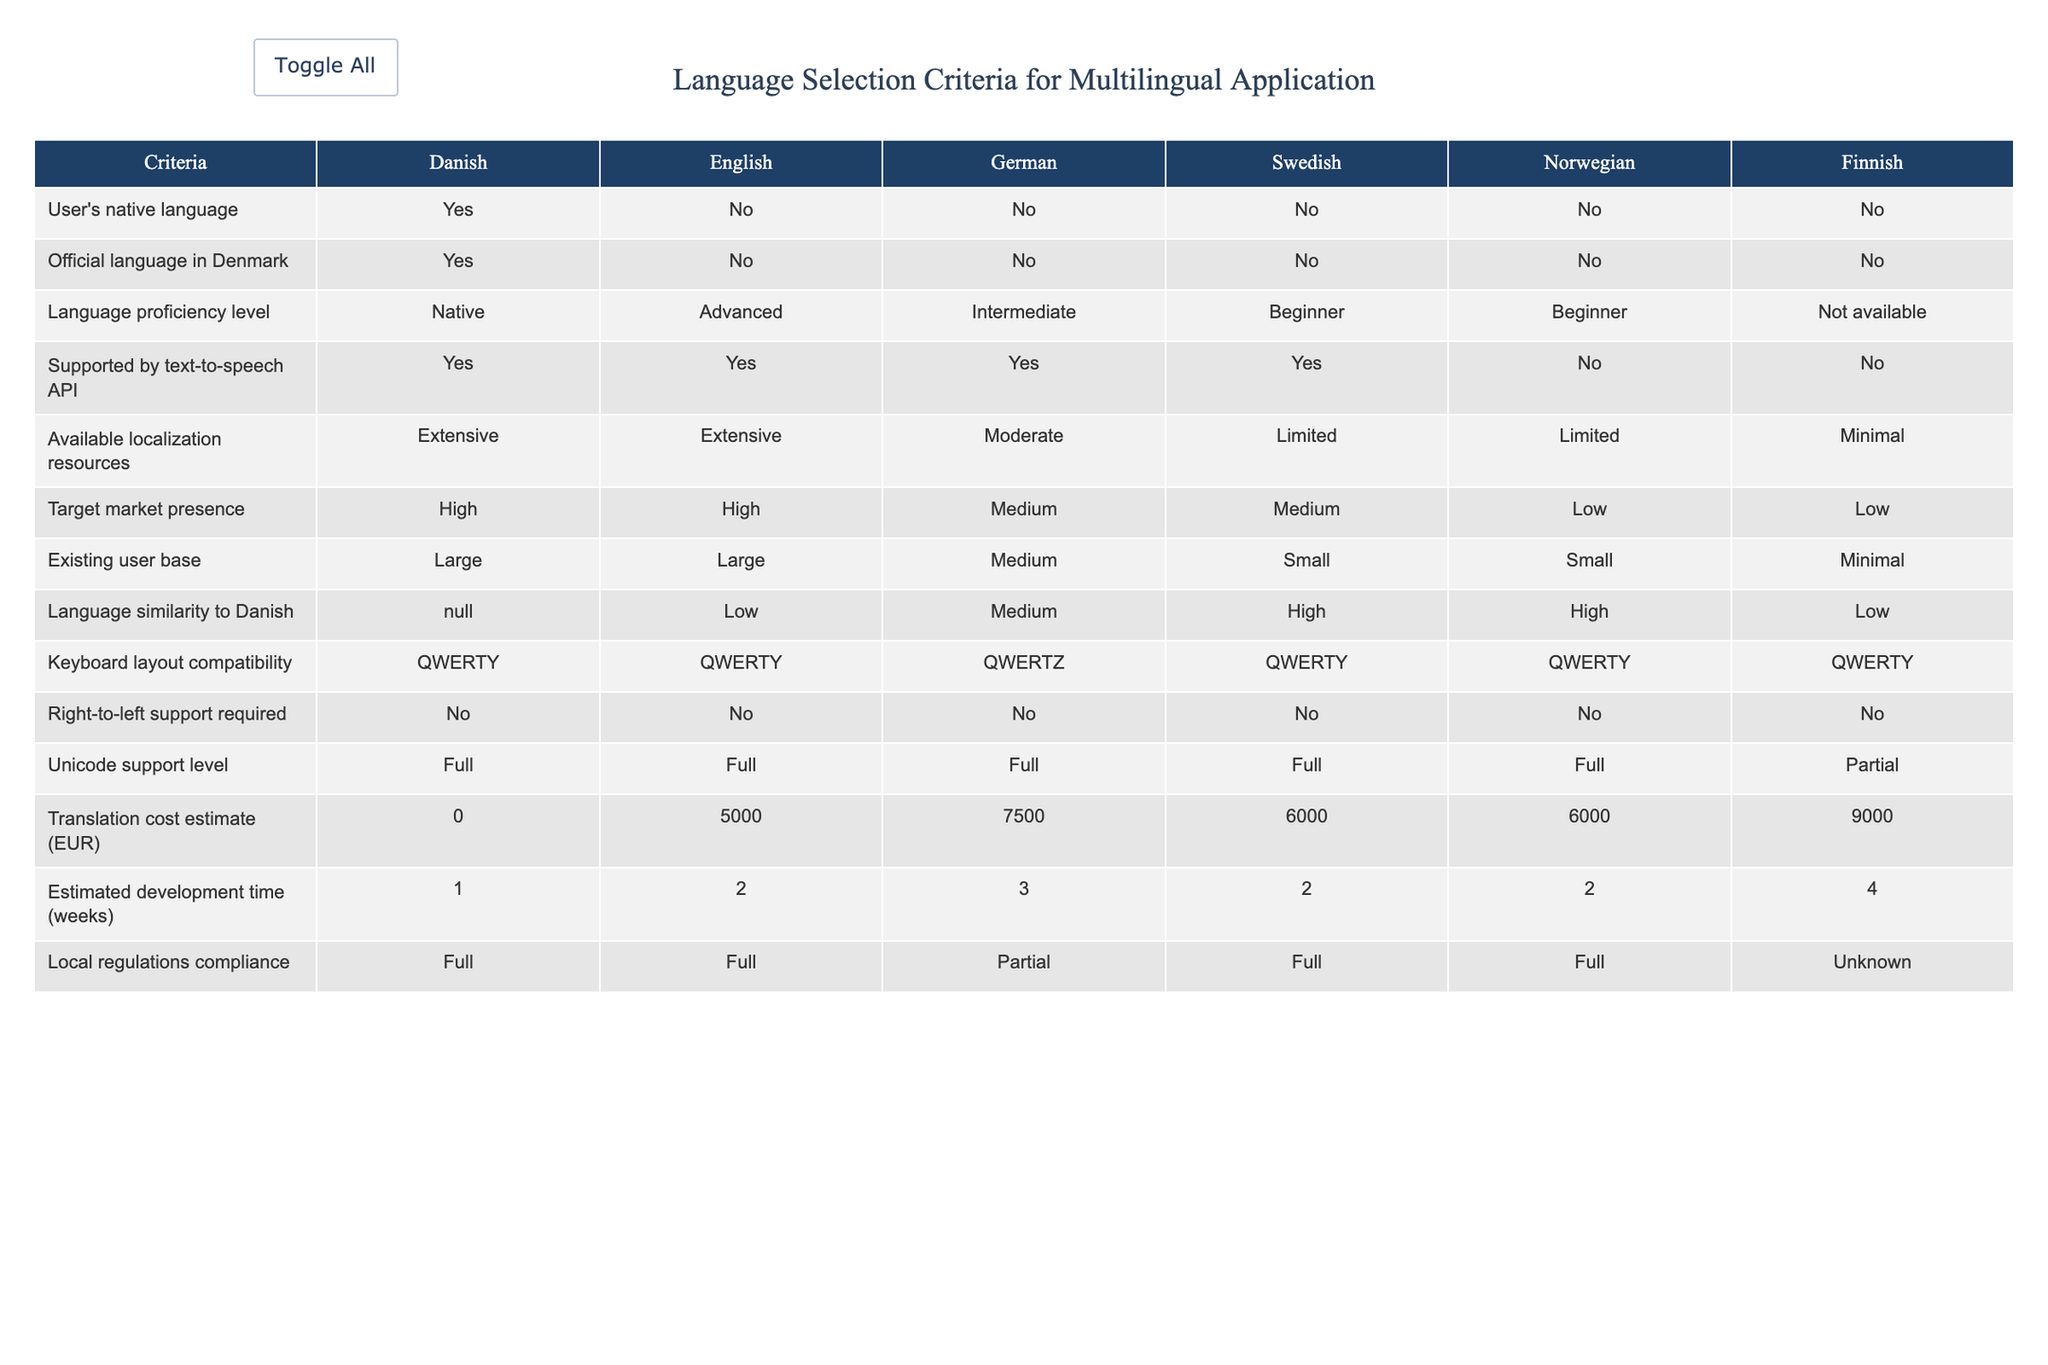What is the translation cost estimate for the German language? The table indicates the translation cost estimate for the German language is 7500 EUR.
Answer: 7500 EUR Which language has the highest target market presence? Both Danish and English are noted to have high target market presence, as indicated in the table under "Target market presence."
Answer: Danish and English Is Finnish supported by a text-to-speech API? The table shows that Finnish is not supported by the text-to-speech API, as indicated with a "No" in the respective column.
Answer: No Which languages have a native language proficiency level? According to the table, only Danish has a native language proficiency level, as the proficiency levels for others range from advanced to beginner or are not available.
Answer: Danish What is the average estimated development time for the languages listed? To find the average estimated development time, we add the development times for all languages (1+2+3+2+2+4 = 14 weeks) and divide by the number of languages (6), resulting in an average of 14/6 = approximately 2.33 weeks.
Answer: 2.33 weeks Does the application need to comply with local regulations for the English language? The table states that the compliance with local regulations for English is full, indicated by "Full" under the respective column.
Answer: Yes Which language has the least available localization resources? The table shows that Finnish has minimal available localization resources, as indicated under "Available localization resources."
Answer: Finnish What is the difference in translation cost between Danish and Swedish? The translation cost for Danish is 0 EUR and for Swedish is 6000 EUR. The difference is 6000 - 0 = 6000 EUR.
Answer: 6000 EUR Which language(s) have large existing user bases? Danish and English are indicated to have large existing user bases as per the "Existing user base" row in the table.
Answer: Danish and English Are there any languages that require right-to-left support? The table specifies that no languages require right-to-left support, as indicated in the respective column.
Answer: No 